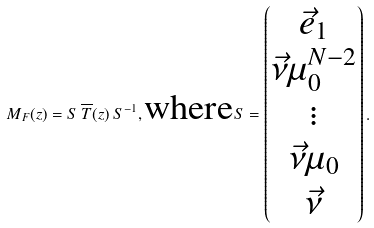<formula> <loc_0><loc_0><loc_500><loc_500>M _ { F } ( z ) = S \, \overline { T } ( z ) \, S ^ { - 1 } , \text {where} S = \begin{pmatrix} \vec { e } _ { 1 } \\ \vec { \nu } \mu _ { 0 } ^ { N - 2 } \\ \vdots \\ \vec { \nu } \mu _ { 0 } \\ \vec { \nu } \end{pmatrix} .</formula> 